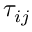<formula> <loc_0><loc_0><loc_500><loc_500>\tau _ { i j }</formula> 